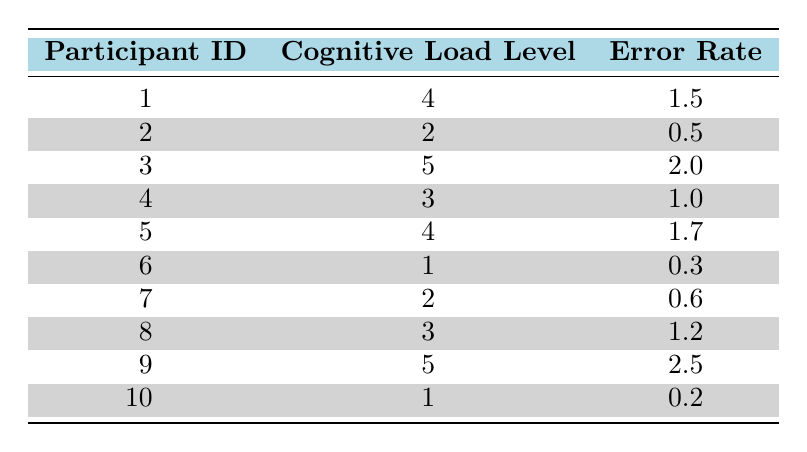What is the cognitive load level of participant 7? Participant 7's cognitive load level is listed in the table next to their ID, which indicates a value of 2.
Answer: 2 What is the error rate for participant 3? The error rate can be found beside participant 3 in the table, showing a value of 2.0.
Answer: 2.0 Which participant has the highest error rate? By scanning the error rates listed in the table, participant 9 has the highest error rate at 2.5.
Answer: Participant 9 What is the average cognitive load level across all participants? To find the average, sum up all the cognitive load levels: (4 + 2 + 5 + 3 + 4 + 1 + 2 + 3 + 5 + 1) = 30 and divide by the number of participants, which is 10. Thus, the average cognitive load level is 30/10 = 3.0.
Answer: 3.0 Does participant 10 have a higher cognitive load than participant 8? Comparing the cognitive load levels, participant 10 has a level of 1, while participant 8 has a level of 3. Therefore, participant 10 does not have a higher cognitive load than participant 8, which makes this statement false.
Answer: No Is there a participant with a cognitive load level of 1 and an error rate lower than 0.5? Participant 10 has a cognitive load level of 1 and an error rate of 0.2, which is lower than 0.5. Thus, there is such a participant, making the statement true.
Answer: Yes What is the total error rate for all participants with a cognitive load level of 5? The cognitive load level of 5 corresponds to participants 3 and 9. Their error rates are 2.0 and 2.5, respectively. Adding these values gives 2.0 + 2.5 = 4.5, which is the total error rate for participants with a cognitive load level of 5.
Answer: 4.5 What is the median error rate of the participants? First, list the error rates in ascending order: 0.2, 0.3, 0.5, 0.6, 1.0, 1.2, 1.5, 1.7, 2.0, 2.5. Since there are 10 participants, the median will be the average of the 5th and 6th values: (1.5 + 1.2) / 2 = 1.35.
Answer: 1.35 Which participant's cognitive load level matches their error rate? After reviewing the table, participant 6 has a cognitive load level of 1 and an error rate of 0.3. However, no participant has matching values, making this statement false.
Answer: No 